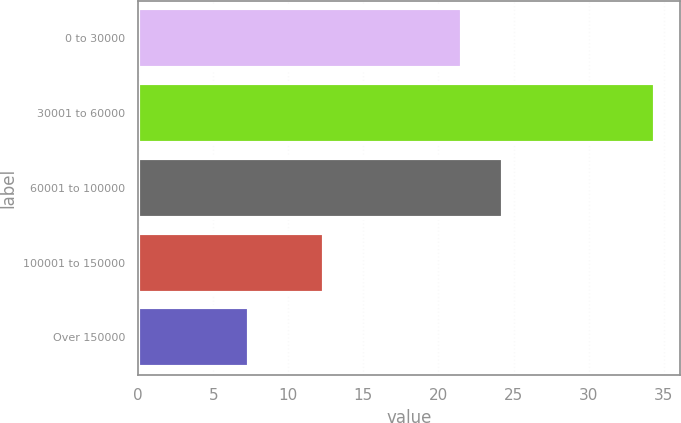Convert chart. <chart><loc_0><loc_0><loc_500><loc_500><bar_chart><fcel>0 to 30000<fcel>30001 to 60000<fcel>60001 to 100000<fcel>100001 to 150000<fcel>Over 150000<nl><fcel>21.6<fcel>34.4<fcel>24.3<fcel>12.4<fcel>7.4<nl></chart> 